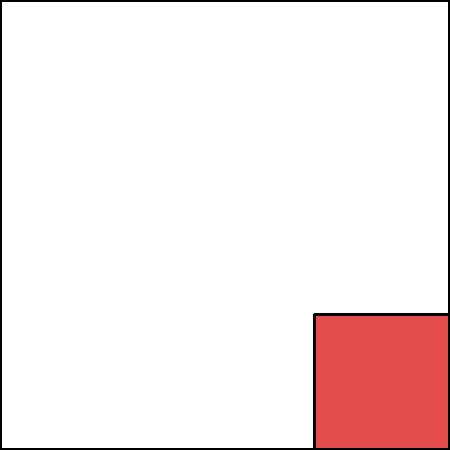In designing a smart home lighting system to complement vibrant silk fabrics, you want to create a color-changing effect that smoothly transitions between neutral and accent colors. If the system uses PWM (Pulse Width Modulation) to control LED brightness, what is the minimum PWM frequency required to avoid visible flicker, considering the human eye's flicker fusion threshold? To determine the minimum PWM frequency required to avoid visible flicker in the smart lighting system, we need to consider the following steps:

1. Understand the flicker fusion threshold:
   The flicker fusion threshold is the frequency at which the human eye perceives a flickering light as a continuous, steady light. This threshold varies among individuals but is generally considered to be around 60 Hz.

2. Account for variation and safety margin:
   To ensure that the lighting appears smooth for all users and under various conditions, it's common to use a frequency significantly higher than the average flicker fusion threshold. A typical rule of thumb is to use at least 2-3 times the threshold frequency.

3. Consider LED response time:
   LEDs can respond very quickly to changes in current, which means they can accurately reproduce the PWM signal. This makes them more susceptible to visible flicker compared to traditional incandescent bulbs.

4. Factor in color-changing capabilities:
   For a system that smoothly transitions between colors, a higher PWM frequency can provide finer control over color mixing and brightness levels.

5. Industry standards and common practices:
   In practice, many LED drivers and controllers operate at PWM frequencies of 1000 Hz (1 kHz) or higher to ensure flicker-free operation and smooth dimming.

Given these considerations, a minimum PWM frequency of 1000 Hz (1 kHz) would be appropriate for this application. This frequency is:
- Well above the human flicker fusion threshold
- Provides a significant safety margin
- Allows for smooth color transitions and dimming
- Aligns with common industry practices for LED lighting control
Answer: 1000 Hz (1 kHz) 